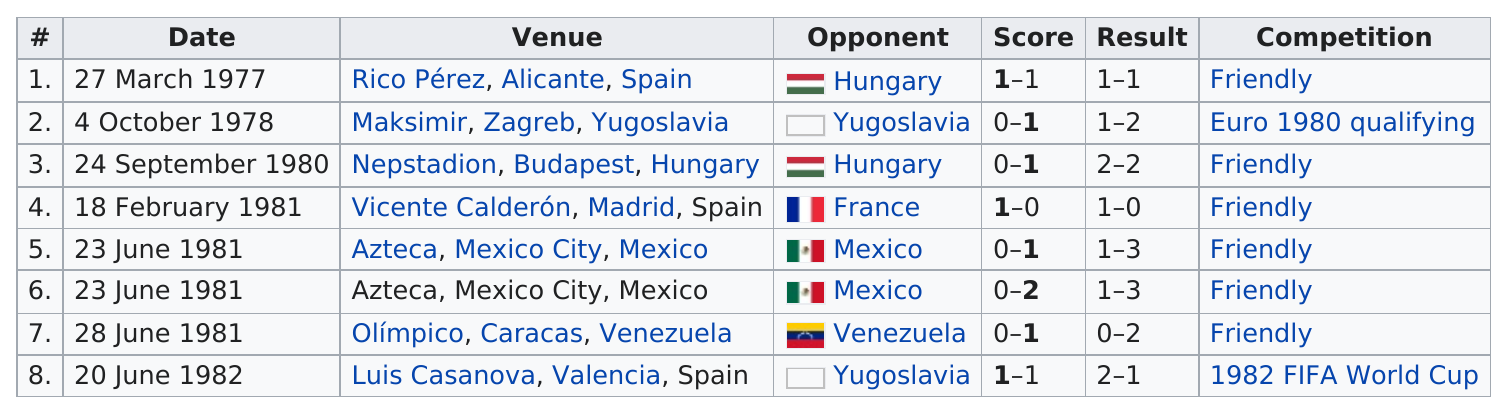Specify some key components in this picture. In the year 1981, he achieved the greatest number of international goals. The date that is listed after March 27, 1977, is October 4, 1978. Juan Gomez Gonzalez scored two international goals against Yugoslavia. Yugoslavia is listed as an opponent for Venezuela. In the year 1981, he scored more goals than any other year. 